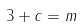Convert formula to latex. <formula><loc_0><loc_0><loc_500><loc_500>3 + c = m</formula> 